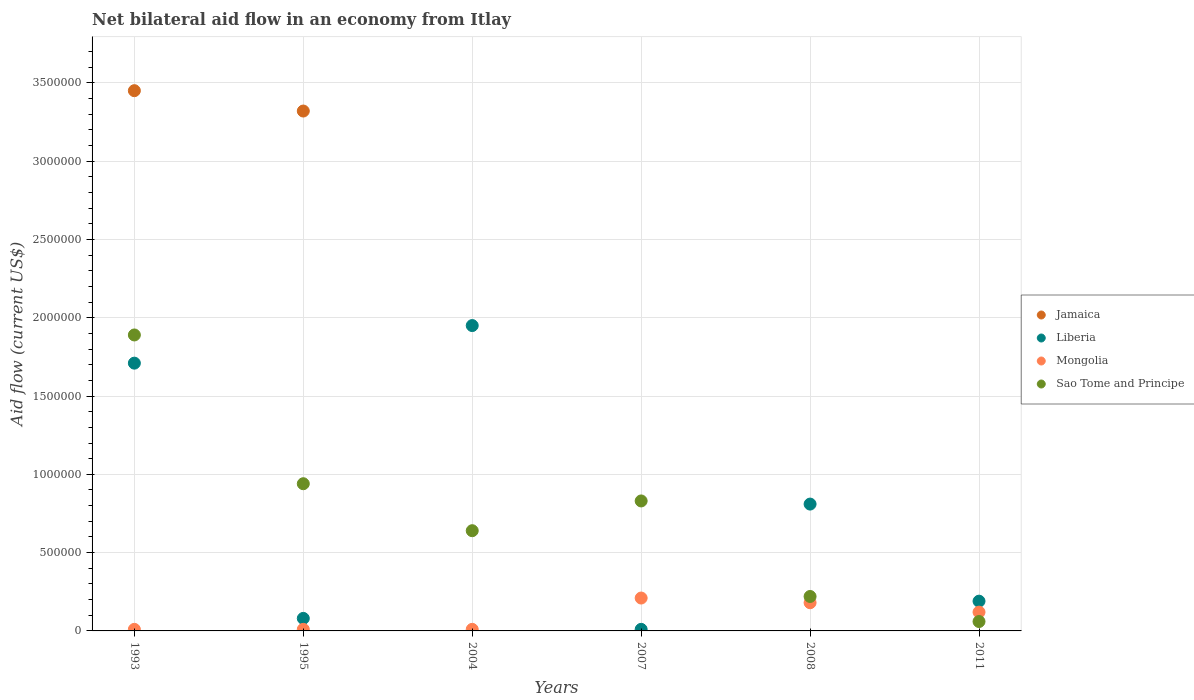How many different coloured dotlines are there?
Give a very brief answer. 4. What is the net bilateral aid flow in Liberia in 2007?
Make the answer very short. 10000. Across all years, what is the minimum net bilateral aid flow in Sao Tome and Principe?
Your answer should be very brief. 6.00e+04. In which year was the net bilateral aid flow in Sao Tome and Principe maximum?
Ensure brevity in your answer.  1993. What is the total net bilateral aid flow in Liberia in the graph?
Ensure brevity in your answer.  4.75e+06. What is the difference between the net bilateral aid flow in Sao Tome and Principe in 2007 and that in 2011?
Provide a short and direct response. 7.70e+05. What is the difference between the net bilateral aid flow in Mongolia in 2011 and the net bilateral aid flow in Liberia in 2007?
Ensure brevity in your answer.  1.10e+05. What is the average net bilateral aid flow in Mongolia per year?
Keep it short and to the point. 9.00e+04. In the year 1993, what is the difference between the net bilateral aid flow in Liberia and net bilateral aid flow in Jamaica?
Give a very brief answer. -1.74e+06. Is the net bilateral aid flow in Sao Tome and Principe in 1995 less than that in 2007?
Provide a succinct answer. No. What is the difference between the highest and the second highest net bilateral aid flow in Sao Tome and Principe?
Your response must be concise. 9.50e+05. What is the difference between the highest and the lowest net bilateral aid flow in Sao Tome and Principe?
Give a very brief answer. 1.83e+06. Is it the case that in every year, the sum of the net bilateral aid flow in Jamaica and net bilateral aid flow in Sao Tome and Principe  is greater than the sum of net bilateral aid flow in Mongolia and net bilateral aid flow in Liberia?
Your answer should be compact. No. Is it the case that in every year, the sum of the net bilateral aid flow in Mongolia and net bilateral aid flow in Jamaica  is greater than the net bilateral aid flow in Sao Tome and Principe?
Your response must be concise. No. Does the net bilateral aid flow in Jamaica monotonically increase over the years?
Give a very brief answer. No. How many years are there in the graph?
Give a very brief answer. 6. Are the values on the major ticks of Y-axis written in scientific E-notation?
Make the answer very short. No. Does the graph contain grids?
Keep it short and to the point. Yes. How are the legend labels stacked?
Your response must be concise. Vertical. What is the title of the graph?
Offer a terse response. Net bilateral aid flow in an economy from Itlay. What is the label or title of the X-axis?
Offer a terse response. Years. What is the label or title of the Y-axis?
Provide a succinct answer. Aid flow (current US$). What is the Aid flow (current US$) of Jamaica in 1993?
Your response must be concise. 3.45e+06. What is the Aid flow (current US$) of Liberia in 1993?
Your response must be concise. 1.71e+06. What is the Aid flow (current US$) of Mongolia in 1993?
Your answer should be compact. 10000. What is the Aid flow (current US$) of Sao Tome and Principe in 1993?
Make the answer very short. 1.89e+06. What is the Aid flow (current US$) in Jamaica in 1995?
Make the answer very short. 3.32e+06. What is the Aid flow (current US$) in Liberia in 1995?
Your response must be concise. 8.00e+04. What is the Aid flow (current US$) of Sao Tome and Principe in 1995?
Your answer should be compact. 9.40e+05. What is the Aid flow (current US$) of Jamaica in 2004?
Your answer should be compact. 0. What is the Aid flow (current US$) of Liberia in 2004?
Keep it short and to the point. 1.95e+06. What is the Aid flow (current US$) in Sao Tome and Principe in 2004?
Offer a very short reply. 6.40e+05. What is the Aid flow (current US$) of Liberia in 2007?
Offer a terse response. 10000. What is the Aid flow (current US$) in Mongolia in 2007?
Give a very brief answer. 2.10e+05. What is the Aid flow (current US$) in Sao Tome and Principe in 2007?
Offer a very short reply. 8.30e+05. What is the Aid flow (current US$) of Liberia in 2008?
Offer a very short reply. 8.10e+05. What is the Aid flow (current US$) in Liberia in 2011?
Offer a very short reply. 1.90e+05. Across all years, what is the maximum Aid flow (current US$) in Jamaica?
Provide a succinct answer. 3.45e+06. Across all years, what is the maximum Aid flow (current US$) in Liberia?
Keep it short and to the point. 1.95e+06. Across all years, what is the maximum Aid flow (current US$) in Mongolia?
Keep it short and to the point. 2.10e+05. Across all years, what is the maximum Aid flow (current US$) of Sao Tome and Principe?
Your response must be concise. 1.89e+06. Across all years, what is the minimum Aid flow (current US$) in Jamaica?
Your response must be concise. 0. Across all years, what is the minimum Aid flow (current US$) of Mongolia?
Ensure brevity in your answer.  10000. What is the total Aid flow (current US$) of Jamaica in the graph?
Provide a succinct answer. 6.77e+06. What is the total Aid flow (current US$) in Liberia in the graph?
Provide a short and direct response. 4.75e+06. What is the total Aid flow (current US$) of Mongolia in the graph?
Ensure brevity in your answer.  5.40e+05. What is the total Aid flow (current US$) in Sao Tome and Principe in the graph?
Make the answer very short. 4.58e+06. What is the difference between the Aid flow (current US$) of Liberia in 1993 and that in 1995?
Make the answer very short. 1.63e+06. What is the difference between the Aid flow (current US$) in Mongolia in 1993 and that in 1995?
Ensure brevity in your answer.  0. What is the difference between the Aid flow (current US$) in Sao Tome and Principe in 1993 and that in 1995?
Your answer should be very brief. 9.50e+05. What is the difference between the Aid flow (current US$) of Liberia in 1993 and that in 2004?
Keep it short and to the point. -2.40e+05. What is the difference between the Aid flow (current US$) of Sao Tome and Principe in 1993 and that in 2004?
Make the answer very short. 1.25e+06. What is the difference between the Aid flow (current US$) in Liberia in 1993 and that in 2007?
Offer a terse response. 1.70e+06. What is the difference between the Aid flow (current US$) of Sao Tome and Principe in 1993 and that in 2007?
Provide a succinct answer. 1.06e+06. What is the difference between the Aid flow (current US$) in Liberia in 1993 and that in 2008?
Provide a succinct answer. 9.00e+05. What is the difference between the Aid flow (current US$) in Sao Tome and Principe in 1993 and that in 2008?
Give a very brief answer. 1.67e+06. What is the difference between the Aid flow (current US$) in Liberia in 1993 and that in 2011?
Keep it short and to the point. 1.52e+06. What is the difference between the Aid flow (current US$) of Mongolia in 1993 and that in 2011?
Your answer should be compact. -1.10e+05. What is the difference between the Aid flow (current US$) of Sao Tome and Principe in 1993 and that in 2011?
Offer a very short reply. 1.83e+06. What is the difference between the Aid flow (current US$) of Liberia in 1995 and that in 2004?
Offer a terse response. -1.87e+06. What is the difference between the Aid flow (current US$) of Liberia in 1995 and that in 2007?
Your answer should be compact. 7.00e+04. What is the difference between the Aid flow (current US$) of Mongolia in 1995 and that in 2007?
Your answer should be compact. -2.00e+05. What is the difference between the Aid flow (current US$) in Liberia in 1995 and that in 2008?
Your answer should be very brief. -7.30e+05. What is the difference between the Aid flow (current US$) in Mongolia in 1995 and that in 2008?
Give a very brief answer. -1.70e+05. What is the difference between the Aid flow (current US$) in Sao Tome and Principe in 1995 and that in 2008?
Offer a very short reply. 7.20e+05. What is the difference between the Aid flow (current US$) in Liberia in 1995 and that in 2011?
Provide a short and direct response. -1.10e+05. What is the difference between the Aid flow (current US$) of Sao Tome and Principe in 1995 and that in 2011?
Your answer should be very brief. 8.80e+05. What is the difference between the Aid flow (current US$) of Liberia in 2004 and that in 2007?
Provide a succinct answer. 1.94e+06. What is the difference between the Aid flow (current US$) in Liberia in 2004 and that in 2008?
Offer a very short reply. 1.14e+06. What is the difference between the Aid flow (current US$) in Mongolia in 2004 and that in 2008?
Provide a succinct answer. -1.70e+05. What is the difference between the Aid flow (current US$) of Liberia in 2004 and that in 2011?
Your answer should be very brief. 1.76e+06. What is the difference between the Aid flow (current US$) of Mongolia in 2004 and that in 2011?
Make the answer very short. -1.10e+05. What is the difference between the Aid flow (current US$) in Sao Tome and Principe in 2004 and that in 2011?
Ensure brevity in your answer.  5.80e+05. What is the difference between the Aid flow (current US$) of Liberia in 2007 and that in 2008?
Your answer should be compact. -8.00e+05. What is the difference between the Aid flow (current US$) in Sao Tome and Principe in 2007 and that in 2008?
Keep it short and to the point. 6.10e+05. What is the difference between the Aid flow (current US$) in Liberia in 2007 and that in 2011?
Ensure brevity in your answer.  -1.80e+05. What is the difference between the Aid flow (current US$) of Mongolia in 2007 and that in 2011?
Ensure brevity in your answer.  9.00e+04. What is the difference between the Aid flow (current US$) of Sao Tome and Principe in 2007 and that in 2011?
Your answer should be compact. 7.70e+05. What is the difference between the Aid flow (current US$) in Liberia in 2008 and that in 2011?
Offer a terse response. 6.20e+05. What is the difference between the Aid flow (current US$) of Mongolia in 2008 and that in 2011?
Ensure brevity in your answer.  6.00e+04. What is the difference between the Aid flow (current US$) of Jamaica in 1993 and the Aid flow (current US$) of Liberia in 1995?
Offer a terse response. 3.37e+06. What is the difference between the Aid flow (current US$) of Jamaica in 1993 and the Aid flow (current US$) of Mongolia in 1995?
Offer a very short reply. 3.44e+06. What is the difference between the Aid flow (current US$) in Jamaica in 1993 and the Aid flow (current US$) in Sao Tome and Principe in 1995?
Your response must be concise. 2.51e+06. What is the difference between the Aid flow (current US$) of Liberia in 1993 and the Aid flow (current US$) of Mongolia in 1995?
Your response must be concise. 1.70e+06. What is the difference between the Aid flow (current US$) in Liberia in 1993 and the Aid flow (current US$) in Sao Tome and Principe in 1995?
Give a very brief answer. 7.70e+05. What is the difference between the Aid flow (current US$) of Mongolia in 1993 and the Aid flow (current US$) of Sao Tome and Principe in 1995?
Offer a terse response. -9.30e+05. What is the difference between the Aid flow (current US$) in Jamaica in 1993 and the Aid flow (current US$) in Liberia in 2004?
Provide a succinct answer. 1.50e+06. What is the difference between the Aid flow (current US$) in Jamaica in 1993 and the Aid flow (current US$) in Mongolia in 2004?
Your response must be concise. 3.44e+06. What is the difference between the Aid flow (current US$) of Jamaica in 1993 and the Aid flow (current US$) of Sao Tome and Principe in 2004?
Offer a terse response. 2.81e+06. What is the difference between the Aid flow (current US$) in Liberia in 1993 and the Aid flow (current US$) in Mongolia in 2004?
Keep it short and to the point. 1.70e+06. What is the difference between the Aid flow (current US$) of Liberia in 1993 and the Aid flow (current US$) of Sao Tome and Principe in 2004?
Provide a short and direct response. 1.07e+06. What is the difference between the Aid flow (current US$) in Mongolia in 1993 and the Aid flow (current US$) in Sao Tome and Principe in 2004?
Your answer should be compact. -6.30e+05. What is the difference between the Aid flow (current US$) in Jamaica in 1993 and the Aid flow (current US$) in Liberia in 2007?
Your response must be concise. 3.44e+06. What is the difference between the Aid flow (current US$) in Jamaica in 1993 and the Aid flow (current US$) in Mongolia in 2007?
Make the answer very short. 3.24e+06. What is the difference between the Aid flow (current US$) of Jamaica in 1993 and the Aid flow (current US$) of Sao Tome and Principe in 2007?
Provide a short and direct response. 2.62e+06. What is the difference between the Aid flow (current US$) of Liberia in 1993 and the Aid flow (current US$) of Mongolia in 2007?
Give a very brief answer. 1.50e+06. What is the difference between the Aid flow (current US$) of Liberia in 1993 and the Aid flow (current US$) of Sao Tome and Principe in 2007?
Provide a short and direct response. 8.80e+05. What is the difference between the Aid flow (current US$) of Mongolia in 1993 and the Aid flow (current US$) of Sao Tome and Principe in 2007?
Provide a succinct answer. -8.20e+05. What is the difference between the Aid flow (current US$) of Jamaica in 1993 and the Aid flow (current US$) of Liberia in 2008?
Keep it short and to the point. 2.64e+06. What is the difference between the Aid flow (current US$) of Jamaica in 1993 and the Aid flow (current US$) of Mongolia in 2008?
Offer a very short reply. 3.27e+06. What is the difference between the Aid flow (current US$) of Jamaica in 1993 and the Aid flow (current US$) of Sao Tome and Principe in 2008?
Offer a very short reply. 3.23e+06. What is the difference between the Aid flow (current US$) in Liberia in 1993 and the Aid flow (current US$) in Mongolia in 2008?
Offer a very short reply. 1.53e+06. What is the difference between the Aid flow (current US$) in Liberia in 1993 and the Aid flow (current US$) in Sao Tome and Principe in 2008?
Provide a succinct answer. 1.49e+06. What is the difference between the Aid flow (current US$) of Mongolia in 1993 and the Aid flow (current US$) of Sao Tome and Principe in 2008?
Provide a short and direct response. -2.10e+05. What is the difference between the Aid flow (current US$) of Jamaica in 1993 and the Aid flow (current US$) of Liberia in 2011?
Offer a very short reply. 3.26e+06. What is the difference between the Aid flow (current US$) of Jamaica in 1993 and the Aid flow (current US$) of Mongolia in 2011?
Provide a succinct answer. 3.33e+06. What is the difference between the Aid flow (current US$) in Jamaica in 1993 and the Aid flow (current US$) in Sao Tome and Principe in 2011?
Ensure brevity in your answer.  3.39e+06. What is the difference between the Aid flow (current US$) in Liberia in 1993 and the Aid flow (current US$) in Mongolia in 2011?
Your answer should be very brief. 1.59e+06. What is the difference between the Aid flow (current US$) of Liberia in 1993 and the Aid flow (current US$) of Sao Tome and Principe in 2011?
Provide a short and direct response. 1.65e+06. What is the difference between the Aid flow (current US$) of Jamaica in 1995 and the Aid flow (current US$) of Liberia in 2004?
Offer a very short reply. 1.37e+06. What is the difference between the Aid flow (current US$) of Jamaica in 1995 and the Aid flow (current US$) of Mongolia in 2004?
Your response must be concise. 3.31e+06. What is the difference between the Aid flow (current US$) in Jamaica in 1995 and the Aid flow (current US$) in Sao Tome and Principe in 2004?
Your response must be concise. 2.68e+06. What is the difference between the Aid flow (current US$) of Liberia in 1995 and the Aid flow (current US$) of Mongolia in 2004?
Make the answer very short. 7.00e+04. What is the difference between the Aid flow (current US$) of Liberia in 1995 and the Aid flow (current US$) of Sao Tome and Principe in 2004?
Your answer should be compact. -5.60e+05. What is the difference between the Aid flow (current US$) of Mongolia in 1995 and the Aid flow (current US$) of Sao Tome and Principe in 2004?
Keep it short and to the point. -6.30e+05. What is the difference between the Aid flow (current US$) of Jamaica in 1995 and the Aid flow (current US$) of Liberia in 2007?
Give a very brief answer. 3.31e+06. What is the difference between the Aid flow (current US$) in Jamaica in 1995 and the Aid flow (current US$) in Mongolia in 2007?
Your response must be concise. 3.11e+06. What is the difference between the Aid flow (current US$) in Jamaica in 1995 and the Aid flow (current US$) in Sao Tome and Principe in 2007?
Make the answer very short. 2.49e+06. What is the difference between the Aid flow (current US$) of Liberia in 1995 and the Aid flow (current US$) of Sao Tome and Principe in 2007?
Offer a terse response. -7.50e+05. What is the difference between the Aid flow (current US$) in Mongolia in 1995 and the Aid flow (current US$) in Sao Tome and Principe in 2007?
Ensure brevity in your answer.  -8.20e+05. What is the difference between the Aid flow (current US$) of Jamaica in 1995 and the Aid flow (current US$) of Liberia in 2008?
Ensure brevity in your answer.  2.51e+06. What is the difference between the Aid flow (current US$) of Jamaica in 1995 and the Aid flow (current US$) of Mongolia in 2008?
Keep it short and to the point. 3.14e+06. What is the difference between the Aid flow (current US$) of Jamaica in 1995 and the Aid flow (current US$) of Sao Tome and Principe in 2008?
Give a very brief answer. 3.10e+06. What is the difference between the Aid flow (current US$) of Liberia in 1995 and the Aid flow (current US$) of Mongolia in 2008?
Ensure brevity in your answer.  -1.00e+05. What is the difference between the Aid flow (current US$) of Liberia in 1995 and the Aid flow (current US$) of Sao Tome and Principe in 2008?
Your answer should be compact. -1.40e+05. What is the difference between the Aid flow (current US$) in Jamaica in 1995 and the Aid flow (current US$) in Liberia in 2011?
Provide a short and direct response. 3.13e+06. What is the difference between the Aid flow (current US$) in Jamaica in 1995 and the Aid flow (current US$) in Mongolia in 2011?
Give a very brief answer. 3.20e+06. What is the difference between the Aid flow (current US$) in Jamaica in 1995 and the Aid flow (current US$) in Sao Tome and Principe in 2011?
Make the answer very short. 3.26e+06. What is the difference between the Aid flow (current US$) of Liberia in 1995 and the Aid flow (current US$) of Sao Tome and Principe in 2011?
Ensure brevity in your answer.  2.00e+04. What is the difference between the Aid flow (current US$) of Liberia in 2004 and the Aid flow (current US$) of Mongolia in 2007?
Your response must be concise. 1.74e+06. What is the difference between the Aid flow (current US$) in Liberia in 2004 and the Aid flow (current US$) in Sao Tome and Principe in 2007?
Provide a short and direct response. 1.12e+06. What is the difference between the Aid flow (current US$) of Mongolia in 2004 and the Aid flow (current US$) of Sao Tome and Principe in 2007?
Offer a terse response. -8.20e+05. What is the difference between the Aid flow (current US$) in Liberia in 2004 and the Aid flow (current US$) in Mongolia in 2008?
Keep it short and to the point. 1.77e+06. What is the difference between the Aid flow (current US$) in Liberia in 2004 and the Aid flow (current US$) in Sao Tome and Principe in 2008?
Make the answer very short. 1.73e+06. What is the difference between the Aid flow (current US$) of Mongolia in 2004 and the Aid flow (current US$) of Sao Tome and Principe in 2008?
Your answer should be compact. -2.10e+05. What is the difference between the Aid flow (current US$) in Liberia in 2004 and the Aid flow (current US$) in Mongolia in 2011?
Your answer should be very brief. 1.83e+06. What is the difference between the Aid flow (current US$) in Liberia in 2004 and the Aid flow (current US$) in Sao Tome and Principe in 2011?
Your answer should be very brief. 1.89e+06. What is the difference between the Aid flow (current US$) in Liberia in 2007 and the Aid flow (current US$) in Sao Tome and Principe in 2008?
Provide a succinct answer. -2.10e+05. What is the difference between the Aid flow (current US$) in Mongolia in 2007 and the Aid flow (current US$) in Sao Tome and Principe in 2008?
Your answer should be very brief. -10000. What is the difference between the Aid flow (current US$) in Mongolia in 2007 and the Aid flow (current US$) in Sao Tome and Principe in 2011?
Provide a succinct answer. 1.50e+05. What is the difference between the Aid flow (current US$) of Liberia in 2008 and the Aid flow (current US$) of Mongolia in 2011?
Provide a succinct answer. 6.90e+05. What is the difference between the Aid flow (current US$) of Liberia in 2008 and the Aid flow (current US$) of Sao Tome and Principe in 2011?
Ensure brevity in your answer.  7.50e+05. What is the average Aid flow (current US$) of Jamaica per year?
Keep it short and to the point. 1.13e+06. What is the average Aid flow (current US$) of Liberia per year?
Offer a very short reply. 7.92e+05. What is the average Aid flow (current US$) of Sao Tome and Principe per year?
Offer a terse response. 7.63e+05. In the year 1993, what is the difference between the Aid flow (current US$) of Jamaica and Aid flow (current US$) of Liberia?
Offer a terse response. 1.74e+06. In the year 1993, what is the difference between the Aid flow (current US$) in Jamaica and Aid flow (current US$) in Mongolia?
Provide a short and direct response. 3.44e+06. In the year 1993, what is the difference between the Aid flow (current US$) of Jamaica and Aid flow (current US$) of Sao Tome and Principe?
Make the answer very short. 1.56e+06. In the year 1993, what is the difference between the Aid flow (current US$) in Liberia and Aid flow (current US$) in Mongolia?
Offer a terse response. 1.70e+06. In the year 1993, what is the difference between the Aid flow (current US$) of Mongolia and Aid flow (current US$) of Sao Tome and Principe?
Keep it short and to the point. -1.88e+06. In the year 1995, what is the difference between the Aid flow (current US$) in Jamaica and Aid flow (current US$) in Liberia?
Your answer should be very brief. 3.24e+06. In the year 1995, what is the difference between the Aid flow (current US$) of Jamaica and Aid flow (current US$) of Mongolia?
Your answer should be compact. 3.31e+06. In the year 1995, what is the difference between the Aid flow (current US$) of Jamaica and Aid flow (current US$) of Sao Tome and Principe?
Your answer should be very brief. 2.38e+06. In the year 1995, what is the difference between the Aid flow (current US$) in Liberia and Aid flow (current US$) in Sao Tome and Principe?
Give a very brief answer. -8.60e+05. In the year 1995, what is the difference between the Aid flow (current US$) of Mongolia and Aid flow (current US$) of Sao Tome and Principe?
Offer a terse response. -9.30e+05. In the year 2004, what is the difference between the Aid flow (current US$) in Liberia and Aid flow (current US$) in Mongolia?
Provide a short and direct response. 1.94e+06. In the year 2004, what is the difference between the Aid flow (current US$) in Liberia and Aid flow (current US$) in Sao Tome and Principe?
Offer a very short reply. 1.31e+06. In the year 2004, what is the difference between the Aid flow (current US$) of Mongolia and Aid flow (current US$) of Sao Tome and Principe?
Your response must be concise. -6.30e+05. In the year 2007, what is the difference between the Aid flow (current US$) in Liberia and Aid flow (current US$) in Mongolia?
Give a very brief answer. -2.00e+05. In the year 2007, what is the difference between the Aid flow (current US$) in Liberia and Aid flow (current US$) in Sao Tome and Principe?
Your response must be concise. -8.20e+05. In the year 2007, what is the difference between the Aid flow (current US$) in Mongolia and Aid flow (current US$) in Sao Tome and Principe?
Offer a very short reply. -6.20e+05. In the year 2008, what is the difference between the Aid flow (current US$) of Liberia and Aid flow (current US$) of Mongolia?
Give a very brief answer. 6.30e+05. In the year 2008, what is the difference between the Aid flow (current US$) of Liberia and Aid flow (current US$) of Sao Tome and Principe?
Keep it short and to the point. 5.90e+05. In the year 2008, what is the difference between the Aid flow (current US$) of Mongolia and Aid flow (current US$) of Sao Tome and Principe?
Your response must be concise. -4.00e+04. In the year 2011, what is the difference between the Aid flow (current US$) in Liberia and Aid flow (current US$) in Mongolia?
Provide a short and direct response. 7.00e+04. In the year 2011, what is the difference between the Aid flow (current US$) of Liberia and Aid flow (current US$) of Sao Tome and Principe?
Provide a short and direct response. 1.30e+05. In the year 2011, what is the difference between the Aid flow (current US$) of Mongolia and Aid flow (current US$) of Sao Tome and Principe?
Make the answer very short. 6.00e+04. What is the ratio of the Aid flow (current US$) in Jamaica in 1993 to that in 1995?
Give a very brief answer. 1.04. What is the ratio of the Aid flow (current US$) of Liberia in 1993 to that in 1995?
Give a very brief answer. 21.38. What is the ratio of the Aid flow (current US$) of Mongolia in 1993 to that in 1995?
Provide a succinct answer. 1. What is the ratio of the Aid flow (current US$) in Sao Tome and Principe in 1993 to that in 1995?
Ensure brevity in your answer.  2.01. What is the ratio of the Aid flow (current US$) in Liberia in 1993 to that in 2004?
Offer a terse response. 0.88. What is the ratio of the Aid flow (current US$) of Sao Tome and Principe in 1993 to that in 2004?
Make the answer very short. 2.95. What is the ratio of the Aid flow (current US$) in Liberia in 1993 to that in 2007?
Make the answer very short. 171. What is the ratio of the Aid flow (current US$) of Mongolia in 1993 to that in 2007?
Keep it short and to the point. 0.05. What is the ratio of the Aid flow (current US$) in Sao Tome and Principe in 1993 to that in 2007?
Keep it short and to the point. 2.28. What is the ratio of the Aid flow (current US$) of Liberia in 1993 to that in 2008?
Offer a terse response. 2.11. What is the ratio of the Aid flow (current US$) of Mongolia in 1993 to that in 2008?
Ensure brevity in your answer.  0.06. What is the ratio of the Aid flow (current US$) in Sao Tome and Principe in 1993 to that in 2008?
Ensure brevity in your answer.  8.59. What is the ratio of the Aid flow (current US$) in Liberia in 1993 to that in 2011?
Your answer should be compact. 9. What is the ratio of the Aid flow (current US$) of Mongolia in 1993 to that in 2011?
Offer a very short reply. 0.08. What is the ratio of the Aid flow (current US$) of Sao Tome and Principe in 1993 to that in 2011?
Your response must be concise. 31.5. What is the ratio of the Aid flow (current US$) of Liberia in 1995 to that in 2004?
Ensure brevity in your answer.  0.04. What is the ratio of the Aid flow (current US$) in Mongolia in 1995 to that in 2004?
Provide a short and direct response. 1. What is the ratio of the Aid flow (current US$) of Sao Tome and Principe in 1995 to that in 2004?
Ensure brevity in your answer.  1.47. What is the ratio of the Aid flow (current US$) of Liberia in 1995 to that in 2007?
Keep it short and to the point. 8. What is the ratio of the Aid flow (current US$) in Mongolia in 1995 to that in 2007?
Your response must be concise. 0.05. What is the ratio of the Aid flow (current US$) of Sao Tome and Principe in 1995 to that in 2007?
Your answer should be compact. 1.13. What is the ratio of the Aid flow (current US$) of Liberia in 1995 to that in 2008?
Offer a terse response. 0.1. What is the ratio of the Aid flow (current US$) in Mongolia in 1995 to that in 2008?
Keep it short and to the point. 0.06. What is the ratio of the Aid flow (current US$) in Sao Tome and Principe in 1995 to that in 2008?
Offer a terse response. 4.27. What is the ratio of the Aid flow (current US$) in Liberia in 1995 to that in 2011?
Provide a succinct answer. 0.42. What is the ratio of the Aid flow (current US$) in Mongolia in 1995 to that in 2011?
Provide a short and direct response. 0.08. What is the ratio of the Aid flow (current US$) of Sao Tome and Principe in 1995 to that in 2011?
Give a very brief answer. 15.67. What is the ratio of the Aid flow (current US$) of Liberia in 2004 to that in 2007?
Your response must be concise. 195. What is the ratio of the Aid flow (current US$) in Mongolia in 2004 to that in 2007?
Make the answer very short. 0.05. What is the ratio of the Aid flow (current US$) in Sao Tome and Principe in 2004 to that in 2007?
Your answer should be compact. 0.77. What is the ratio of the Aid flow (current US$) in Liberia in 2004 to that in 2008?
Keep it short and to the point. 2.41. What is the ratio of the Aid flow (current US$) in Mongolia in 2004 to that in 2008?
Your answer should be very brief. 0.06. What is the ratio of the Aid flow (current US$) of Sao Tome and Principe in 2004 to that in 2008?
Your response must be concise. 2.91. What is the ratio of the Aid flow (current US$) in Liberia in 2004 to that in 2011?
Ensure brevity in your answer.  10.26. What is the ratio of the Aid flow (current US$) of Mongolia in 2004 to that in 2011?
Your answer should be very brief. 0.08. What is the ratio of the Aid flow (current US$) in Sao Tome and Principe in 2004 to that in 2011?
Your answer should be very brief. 10.67. What is the ratio of the Aid flow (current US$) in Liberia in 2007 to that in 2008?
Offer a very short reply. 0.01. What is the ratio of the Aid flow (current US$) in Sao Tome and Principe in 2007 to that in 2008?
Provide a succinct answer. 3.77. What is the ratio of the Aid flow (current US$) in Liberia in 2007 to that in 2011?
Ensure brevity in your answer.  0.05. What is the ratio of the Aid flow (current US$) in Mongolia in 2007 to that in 2011?
Offer a terse response. 1.75. What is the ratio of the Aid flow (current US$) in Sao Tome and Principe in 2007 to that in 2011?
Provide a succinct answer. 13.83. What is the ratio of the Aid flow (current US$) of Liberia in 2008 to that in 2011?
Ensure brevity in your answer.  4.26. What is the ratio of the Aid flow (current US$) of Mongolia in 2008 to that in 2011?
Your answer should be very brief. 1.5. What is the ratio of the Aid flow (current US$) of Sao Tome and Principe in 2008 to that in 2011?
Make the answer very short. 3.67. What is the difference between the highest and the second highest Aid flow (current US$) in Liberia?
Ensure brevity in your answer.  2.40e+05. What is the difference between the highest and the second highest Aid flow (current US$) in Mongolia?
Provide a succinct answer. 3.00e+04. What is the difference between the highest and the second highest Aid flow (current US$) of Sao Tome and Principe?
Offer a terse response. 9.50e+05. What is the difference between the highest and the lowest Aid flow (current US$) of Jamaica?
Provide a succinct answer. 3.45e+06. What is the difference between the highest and the lowest Aid flow (current US$) in Liberia?
Your answer should be very brief. 1.94e+06. What is the difference between the highest and the lowest Aid flow (current US$) in Sao Tome and Principe?
Provide a short and direct response. 1.83e+06. 